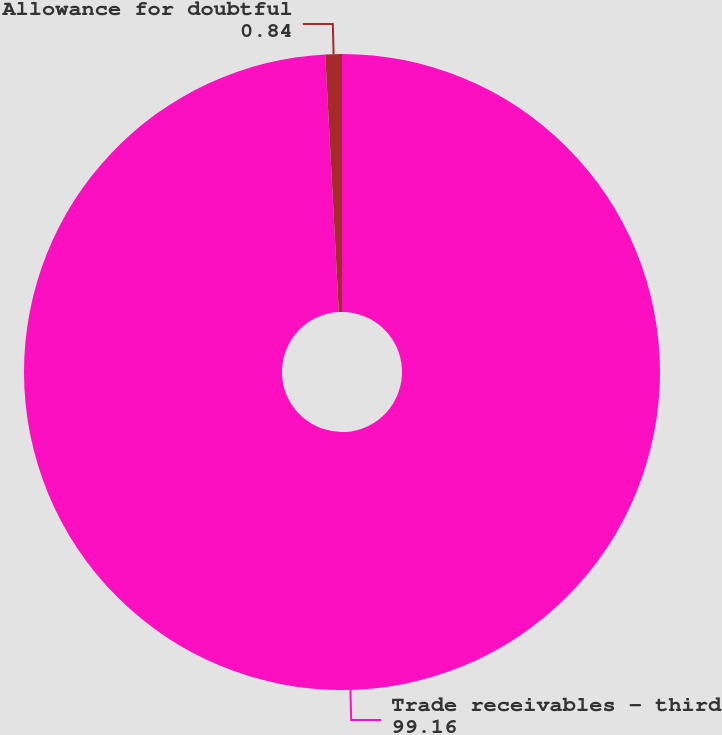Convert chart to OTSL. <chart><loc_0><loc_0><loc_500><loc_500><pie_chart><fcel>Trade receivables - third<fcel>Allowance for doubtful<nl><fcel>99.16%<fcel>0.84%<nl></chart> 